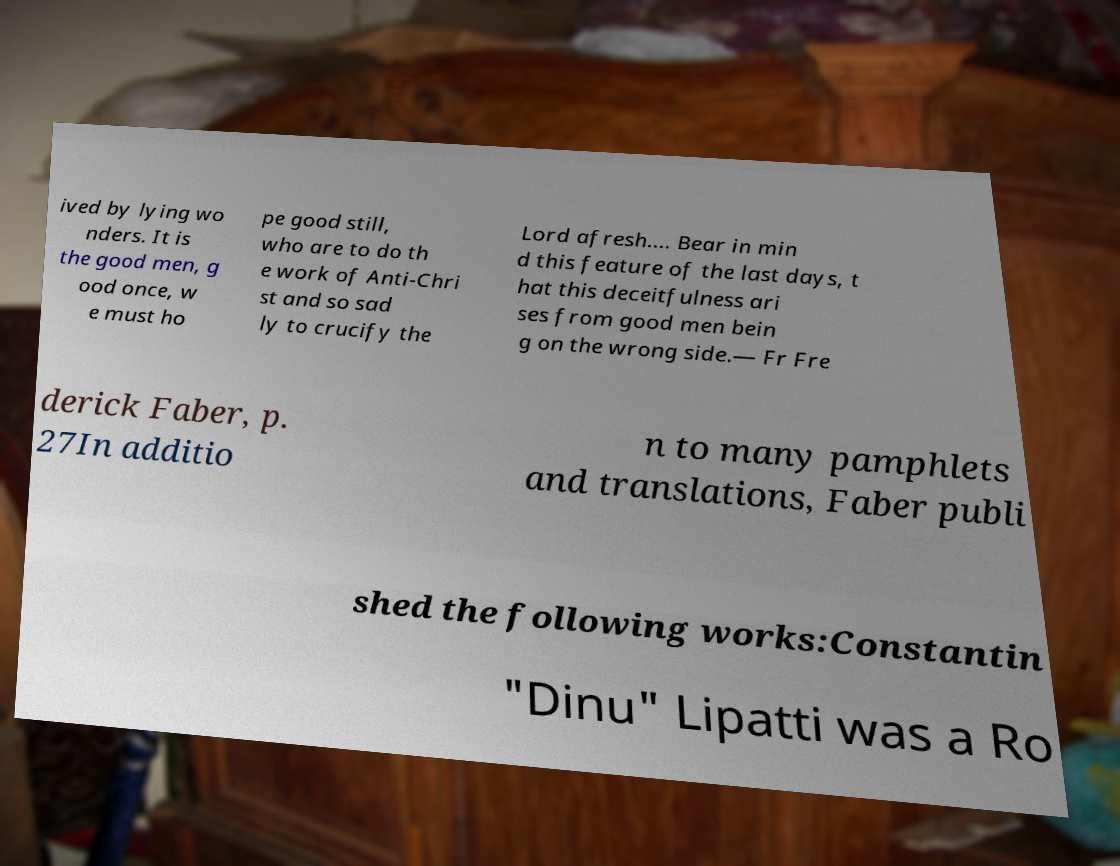Can you read and provide the text displayed in the image?This photo seems to have some interesting text. Can you extract and type it out for me? ived by lying wo nders. It is the good men, g ood once, w e must ho pe good still, who are to do th e work of Anti-Chri st and so sad ly to crucify the Lord afresh…. Bear in min d this feature of the last days, t hat this deceitfulness ari ses from good men bein g on the wrong side.— Fr Fre derick Faber, p. 27In additio n to many pamphlets and translations, Faber publi shed the following works:Constantin "Dinu" Lipatti was a Ro 